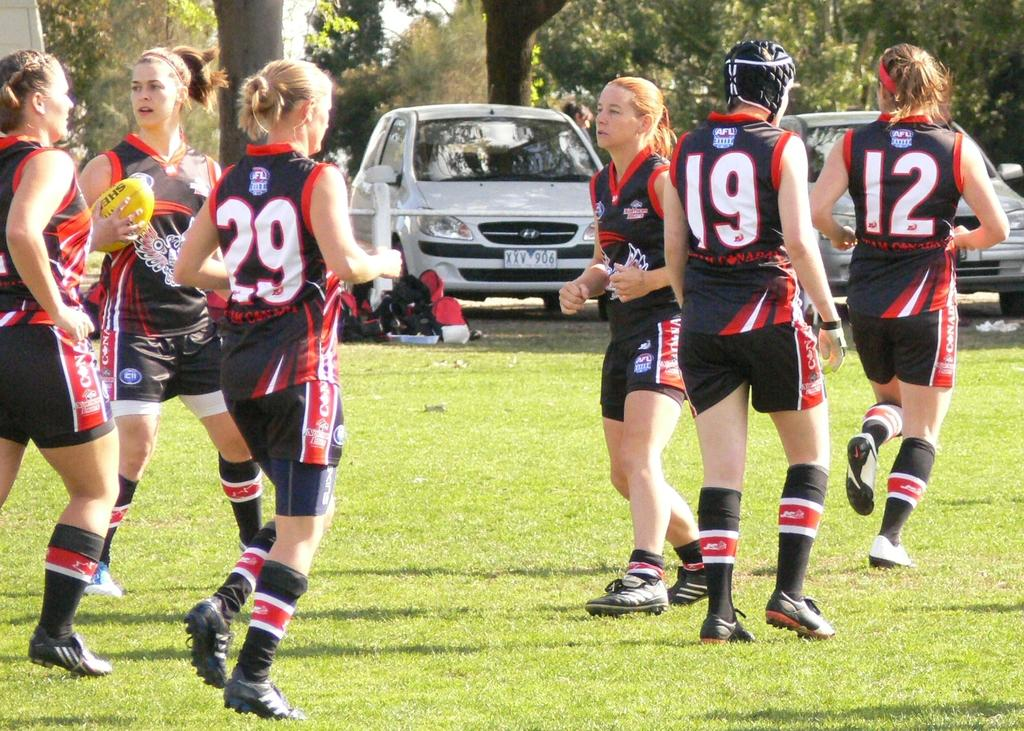How many women are present in the image? There are 6 women in the image. What are the women doing in the image? The women are playing a game on a grass field. What can be seen in the background of the image? There are trees and vehicles visible on a road in the background of the image. What type of notebook is being used by the fireman in the image? There is no fireman or notebook present in the image. 